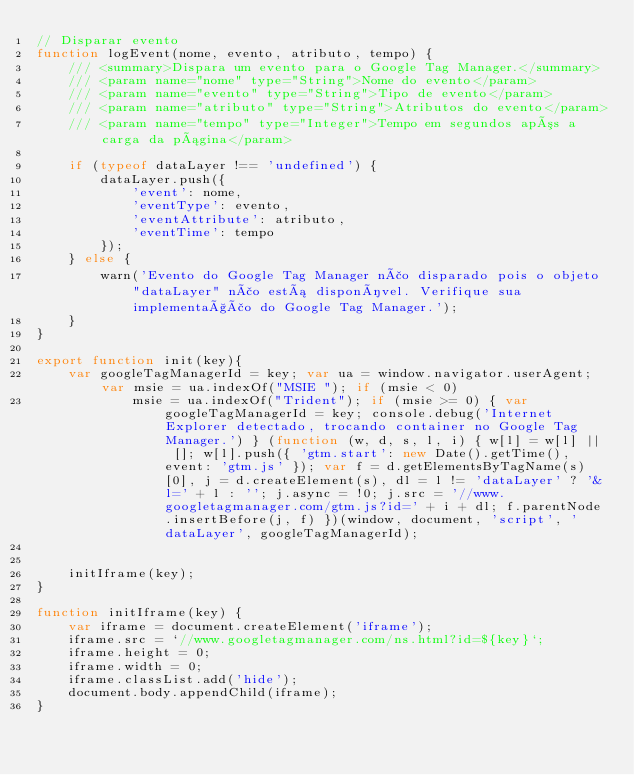Convert code to text. <code><loc_0><loc_0><loc_500><loc_500><_JavaScript_>// Disparar evento
function logEvent(nome, evento, atributo, tempo) {
	/// <summary>Dispara um evento para o Google Tag Manager.</summary>
	/// <param name="nome" type="String">Nome do evento</param>
	/// <param name="evento" type="String">Tipo de evento</param>
	/// <param name="atributo" type="String">Atributos do evento</param>
	/// <param name="tempo" type="Integer">Tempo em segundos após a carga da página</param>

	if (typeof dataLayer !== 'undefined') {
		dataLayer.push({
			'event': nome,
			'eventType': evento,
			'eventAttribute': atributo,
			'eventTime': tempo
		});
	} else {
		warn('Evento do Google Tag Manager não disparado pois o objeto "dataLayer" não está disponível. Verifique sua implementação do Google Tag Manager.');
	}
}

export function init(key){
	var googleTagManagerId = key; var ua = window.navigator.userAgent; var msie = ua.indexOf("MSIE "); if (msie < 0)
			msie = ua.indexOf("Trident"); if (msie >= 0) { var googleTagManagerId = key; console.debug('Internet Explorer detectado, trocando container no Google Tag Manager.') } (function (w, d, s, l, i) { w[l] = w[l] || []; w[l].push({ 'gtm.start': new Date().getTime(), event: 'gtm.js' }); var f = d.getElementsByTagName(s)[0], j = d.createElement(s), dl = l != 'dataLayer' ? '&l=' + l : ''; j.async = !0; j.src = '//www.googletagmanager.com/gtm.js?id=' + i + dl; f.parentNode.insertBefore(j, f) })(window, document, 'script', 'dataLayer', googleTagManagerId);


	initIframe(key);
}

function initIframe(key) {
	var iframe = document.createElement('iframe');
	iframe.src = `//www.googletagmanager.com/ns.html?id=${key}`;
	iframe.height = 0;
	iframe.width = 0;
	iframe.classList.add('hide');
	document.body.appendChild(iframe);
}
</code> 